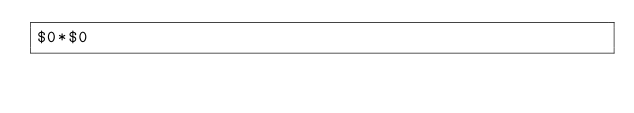<code> <loc_0><loc_0><loc_500><loc_500><_Awk_>$0*$0</code> 